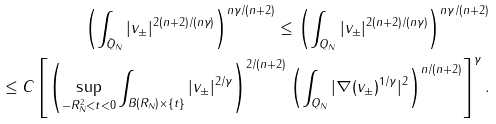Convert formula to latex. <formula><loc_0><loc_0><loc_500><loc_500>\left ( \int _ { \bar { Q } _ { N } } | v _ { \pm } | ^ { 2 ( n + 2 ) / ( n \gamma ) } \right ) ^ { n \gamma / ( n + 2 ) } \leq \left ( \int _ { Q _ { N } } | v _ { \pm } | ^ { 2 ( n + 2 ) / ( n \gamma ) } \right ) ^ { n \gamma / ( n + 2 ) } \\ \leq C \left [ \left ( \sup _ { - R _ { N } ^ { 2 } < t < 0 } \int _ { B ( R _ { N } ) \times \{ t \} } | v _ { \pm } | ^ { 2 / \gamma } \right ) ^ { 2 / ( n + 2 ) } \left ( \int _ { Q _ { N } } | \nabla ( v _ { \pm } ) ^ { 1 / \gamma } | ^ { 2 } \right ) ^ { n / ( n + 2 ) } \right ] ^ { \gamma } .</formula> 